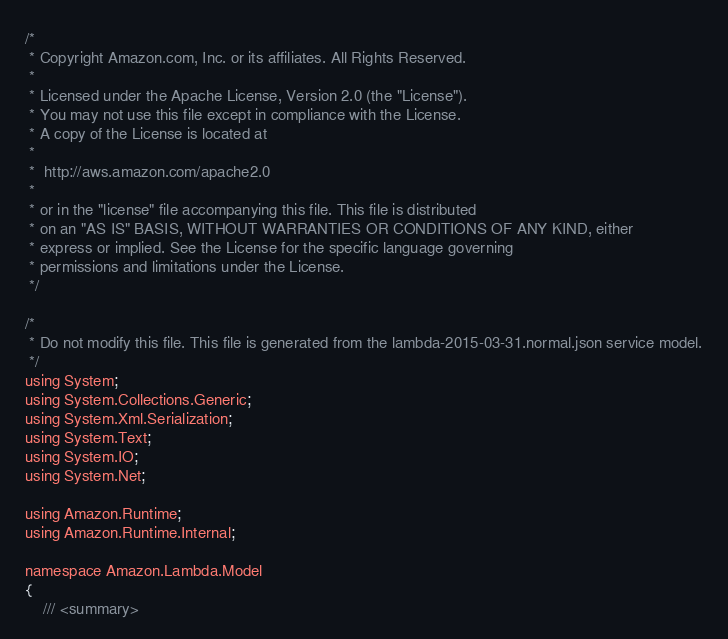<code> <loc_0><loc_0><loc_500><loc_500><_C#_>/*
 * Copyright Amazon.com, Inc. or its affiliates. All Rights Reserved.
 * 
 * Licensed under the Apache License, Version 2.0 (the "License").
 * You may not use this file except in compliance with the License.
 * A copy of the License is located at
 * 
 *  http://aws.amazon.com/apache2.0
 * 
 * or in the "license" file accompanying this file. This file is distributed
 * on an "AS IS" BASIS, WITHOUT WARRANTIES OR CONDITIONS OF ANY KIND, either
 * express or implied. See the License for the specific language governing
 * permissions and limitations under the License.
 */

/*
 * Do not modify this file. This file is generated from the lambda-2015-03-31.normal.json service model.
 */
using System;
using System.Collections.Generic;
using System.Xml.Serialization;
using System.Text;
using System.IO;
using System.Net;

using Amazon.Runtime;
using Amazon.Runtime.Internal;

namespace Amazon.Lambda.Model
{
    /// <summary></code> 